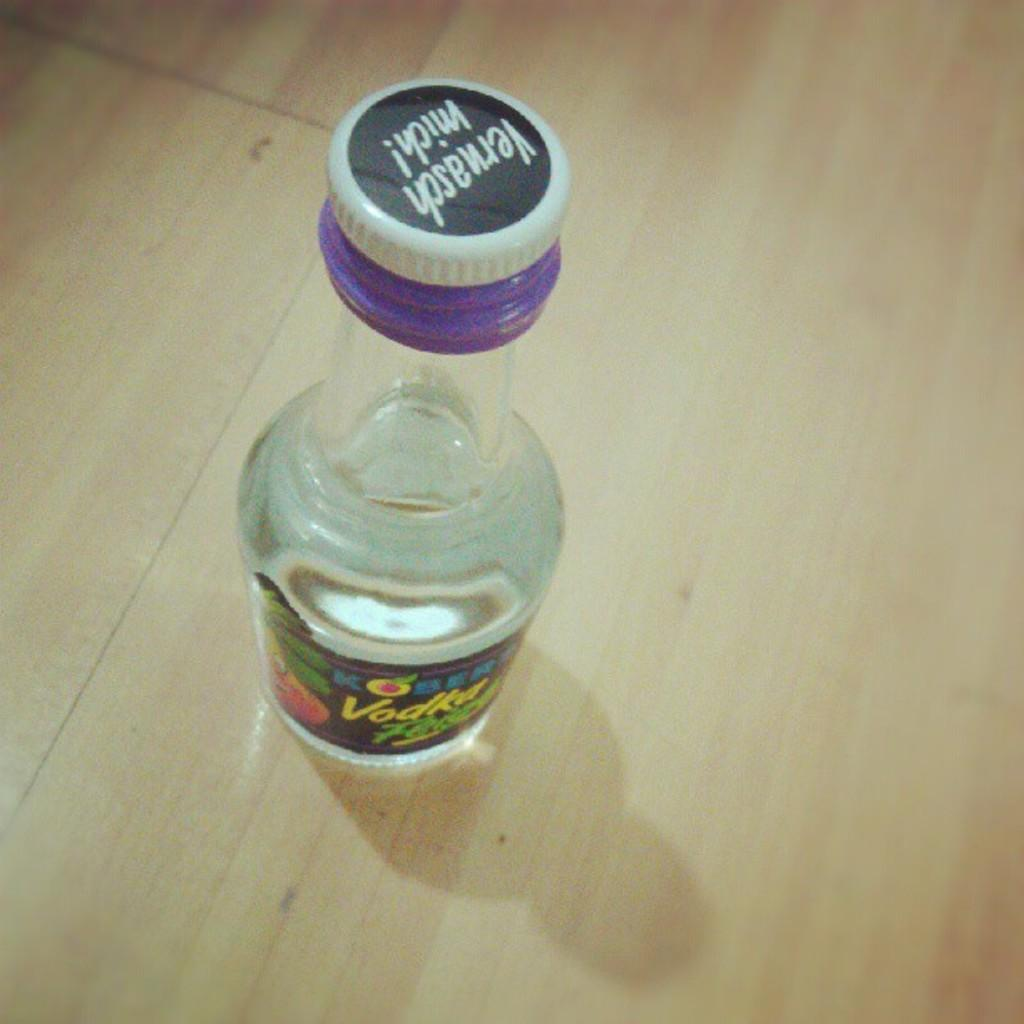What object is visible in the image that is made of glass? There is a glass bottle in the image. Where is the glass bottle located in the image? The glass bottle is placed on a wooden table. How many legs can be seen supporting the glass bottle in the image? The glass bottle is not supported by any legs; it is placed on a wooden table. 